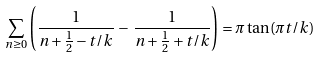<formula> <loc_0><loc_0><loc_500><loc_500>\sum _ { n \geq 0 } \left ( \frac { 1 } { n + \frac { 1 } { 2 } - t / k } \, - \, \frac { 1 } { n + \frac { 1 } { 2 } + t / k } \right ) = \pi \tan ( \pi t / k )</formula> 